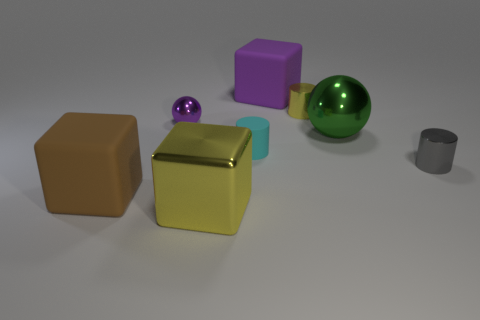Is the material of the tiny cyan object the same as the large green object?
Your answer should be compact. No. Are there an equal number of small metallic things that are right of the small shiny sphere and cyan matte objects?
Your answer should be very brief. No. What number of tiny things are made of the same material as the tiny yellow cylinder?
Your answer should be compact. 2. Are there fewer blue metallic things than large purple objects?
Your response must be concise. Yes. Do the large rubber object behind the gray shiny object and the small rubber cylinder have the same color?
Provide a short and direct response. No. How many metal objects are left of the yellow object that is left of the block behind the tiny gray cylinder?
Keep it short and to the point. 1. There is a large sphere; how many gray metal cylinders are behind it?
Your answer should be compact. 0. There is another big shiny object that is the same shape as the brown thing; what is its color?
Offer a very short reply. Yellow. There is a big thing that is in front of the tiny yellow metallic thing and to the right of the shiny block; what is it made of?
Ensure brevity in your answer.  Metal. Is the size of the yellow object that is behind the cyan matte thing the same as the cyan thing?
Ensure brevity in your answer.  Yes. 